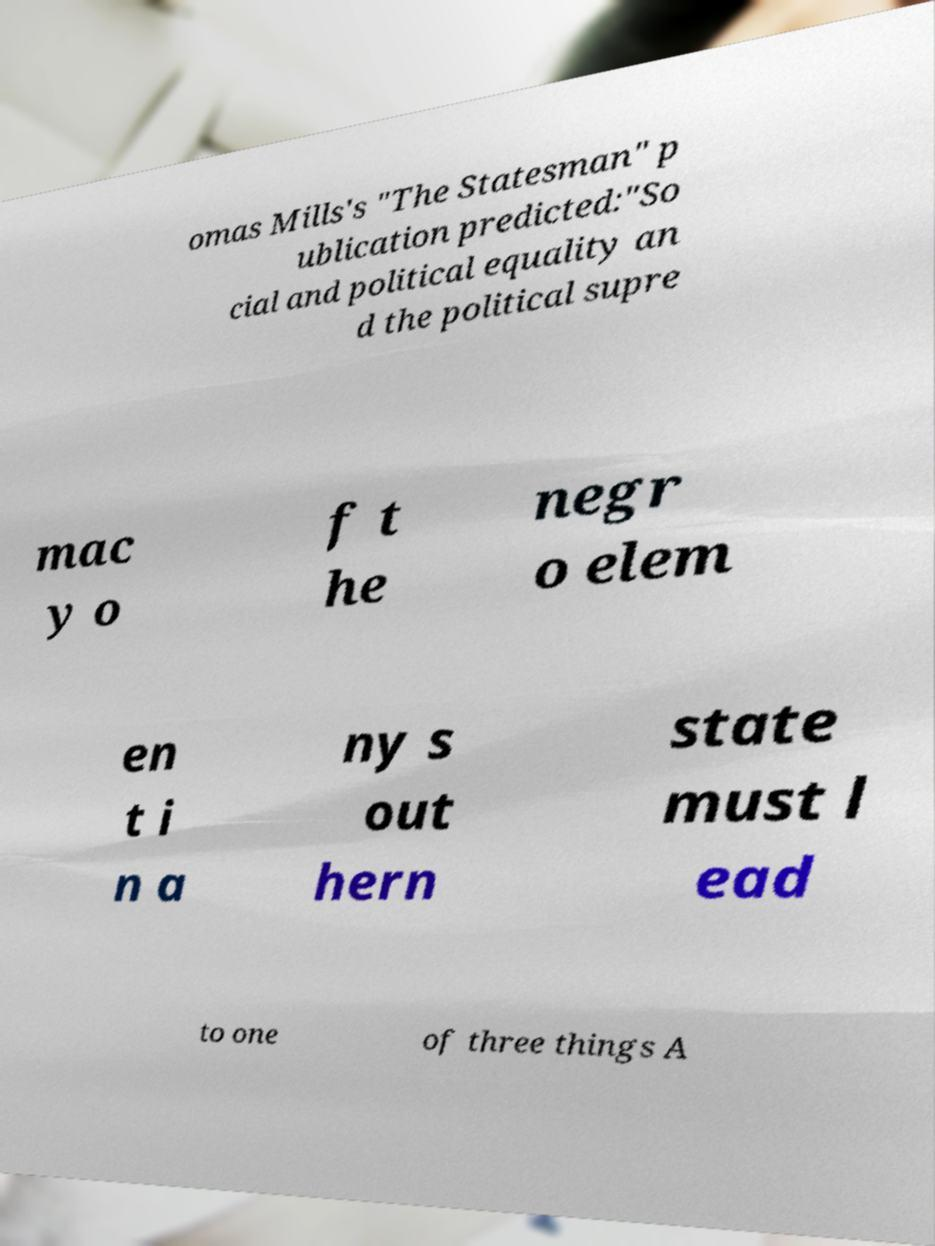For documentation purposes, I need the text within this image transcribed. Could you provide that? omas Mills's "The Statesman" p ublication predicted:"So cial and political equality an d the political supre mac y o f t he negr o elem en t i n a ny s out hern state must l ead to one of three things A 